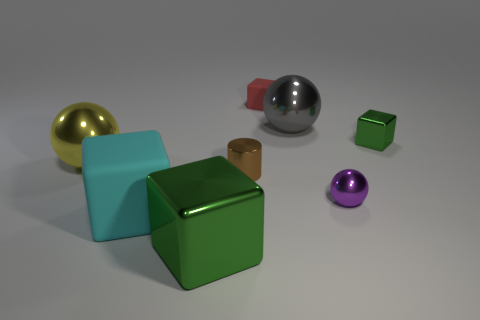There is a tiny block that is to the right of the small red rubber block; is there a small purple metallic object in front of it?
Your response must be concise. Yes. What is the cyan block made of?
Make the answer very short. Rubber. Are the object left of the big cyan matte cube and the thing behind the large gray shiny sphere made of the same material?
Your answer should be compact. No. Are there any other things that have the same color as the small shiny cube?
Your response must be concise. Yes. There is another small metallic object that is the same shape as the red thing; what color is it?
Offer a very short reply. Green. What size is the cube that is both behind the cyan thing and to the left of the gray sphere?
Your response must be concise. Small. Do the green thing behind the yellow metal thing and the tiny thing that is in front of the cylinder have the same shape?
Make the answer very short. No. What is the shape of the small object that is the same color as the large metallic cube?
Your answer should be very brief. Cube. What number of big spheres have the same material as the brown cylinder?
Ensure brevity in your answer.  2. The large shiny object that is behind the large cyan matte thing and left of the red rubber thing has what shape?
Ensure brevity in your answer.  Sphere. 